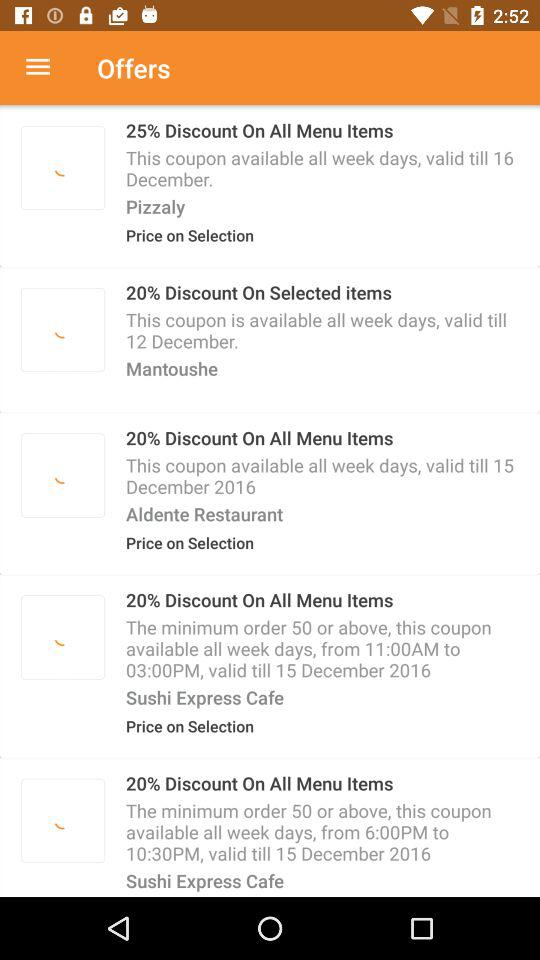How many coupons have a minimum order of 50 or above?
Answer the question using a single word or phrase. 2 